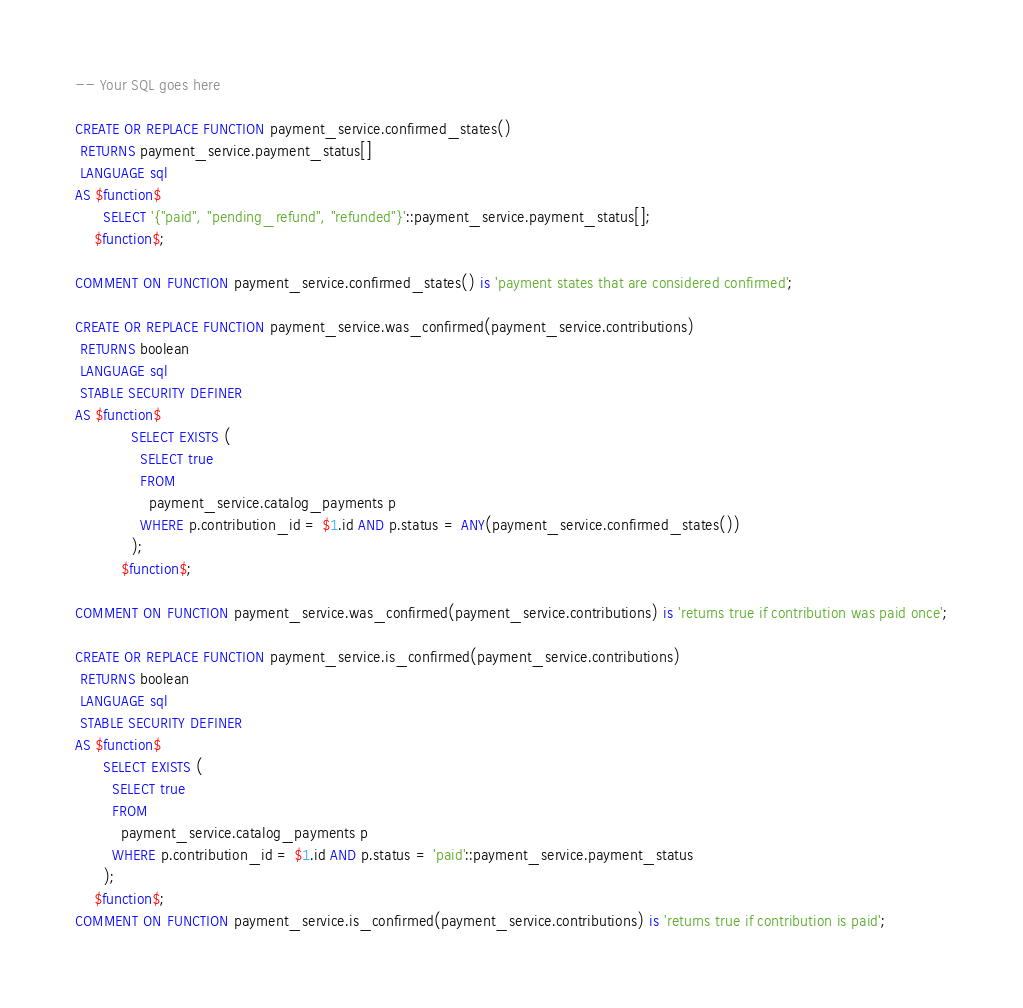<code> <loc_0><loc_0><loc_500><loc_500><_SQL_>-- Your SQL goes here

CREATE OR REPLACE FUNCTION payment_service.confirmed_states()
 RETURNS payment_service.payment_status[]
 LANGUAGE sql
AS $function$
      SELECT '{"paid", "pending_refund", "refunded"}'::payment_service.payment_status[];
    $function$;

COMMENT ON FUNCTION payment_service.confirmed_states() is 'payment states that are considered confirmed';

CREATE OR REPLACE FUNCTION payment_service.was_confirmed(payment_service.contributions)
 RETURNS boolean
 LANGUAGE sql
 STABLE SECURITY DEFINER
AS $function$
            SELECT EXISTS (
              SELECT true
              FROM
                payment_service.catalog_payments p
              WHERE p.contribution_id = $1.id AND p.status = ANY(payment_service.confirmed_states())
            );
          $function$;

COMMENT ON FUNCTION payment_service.was_confirmed(payment_service.contributions) is 'returns true if contribution was paid once';

CREATE OR REPLACE FUNCTION payment_service.is_confirmed(payment_service.contributions)
 RETURNS boolean
 LANGUAGE sql
 STABLE SECURITY DEFINER
AS $function$
      SELECT EXISTS (
        SELECT true
        FROM
          payment_service.catalog_payments p
        WHERE p.contribution_id = $1.id AND p.status = 'paid'::payment_service.payment_status
      );
    $function$;
COMMENT ON FUNCTION payment_service.is_confirmed(payment_service.contributions) is 'returns true if contribution is paid';
</code> 